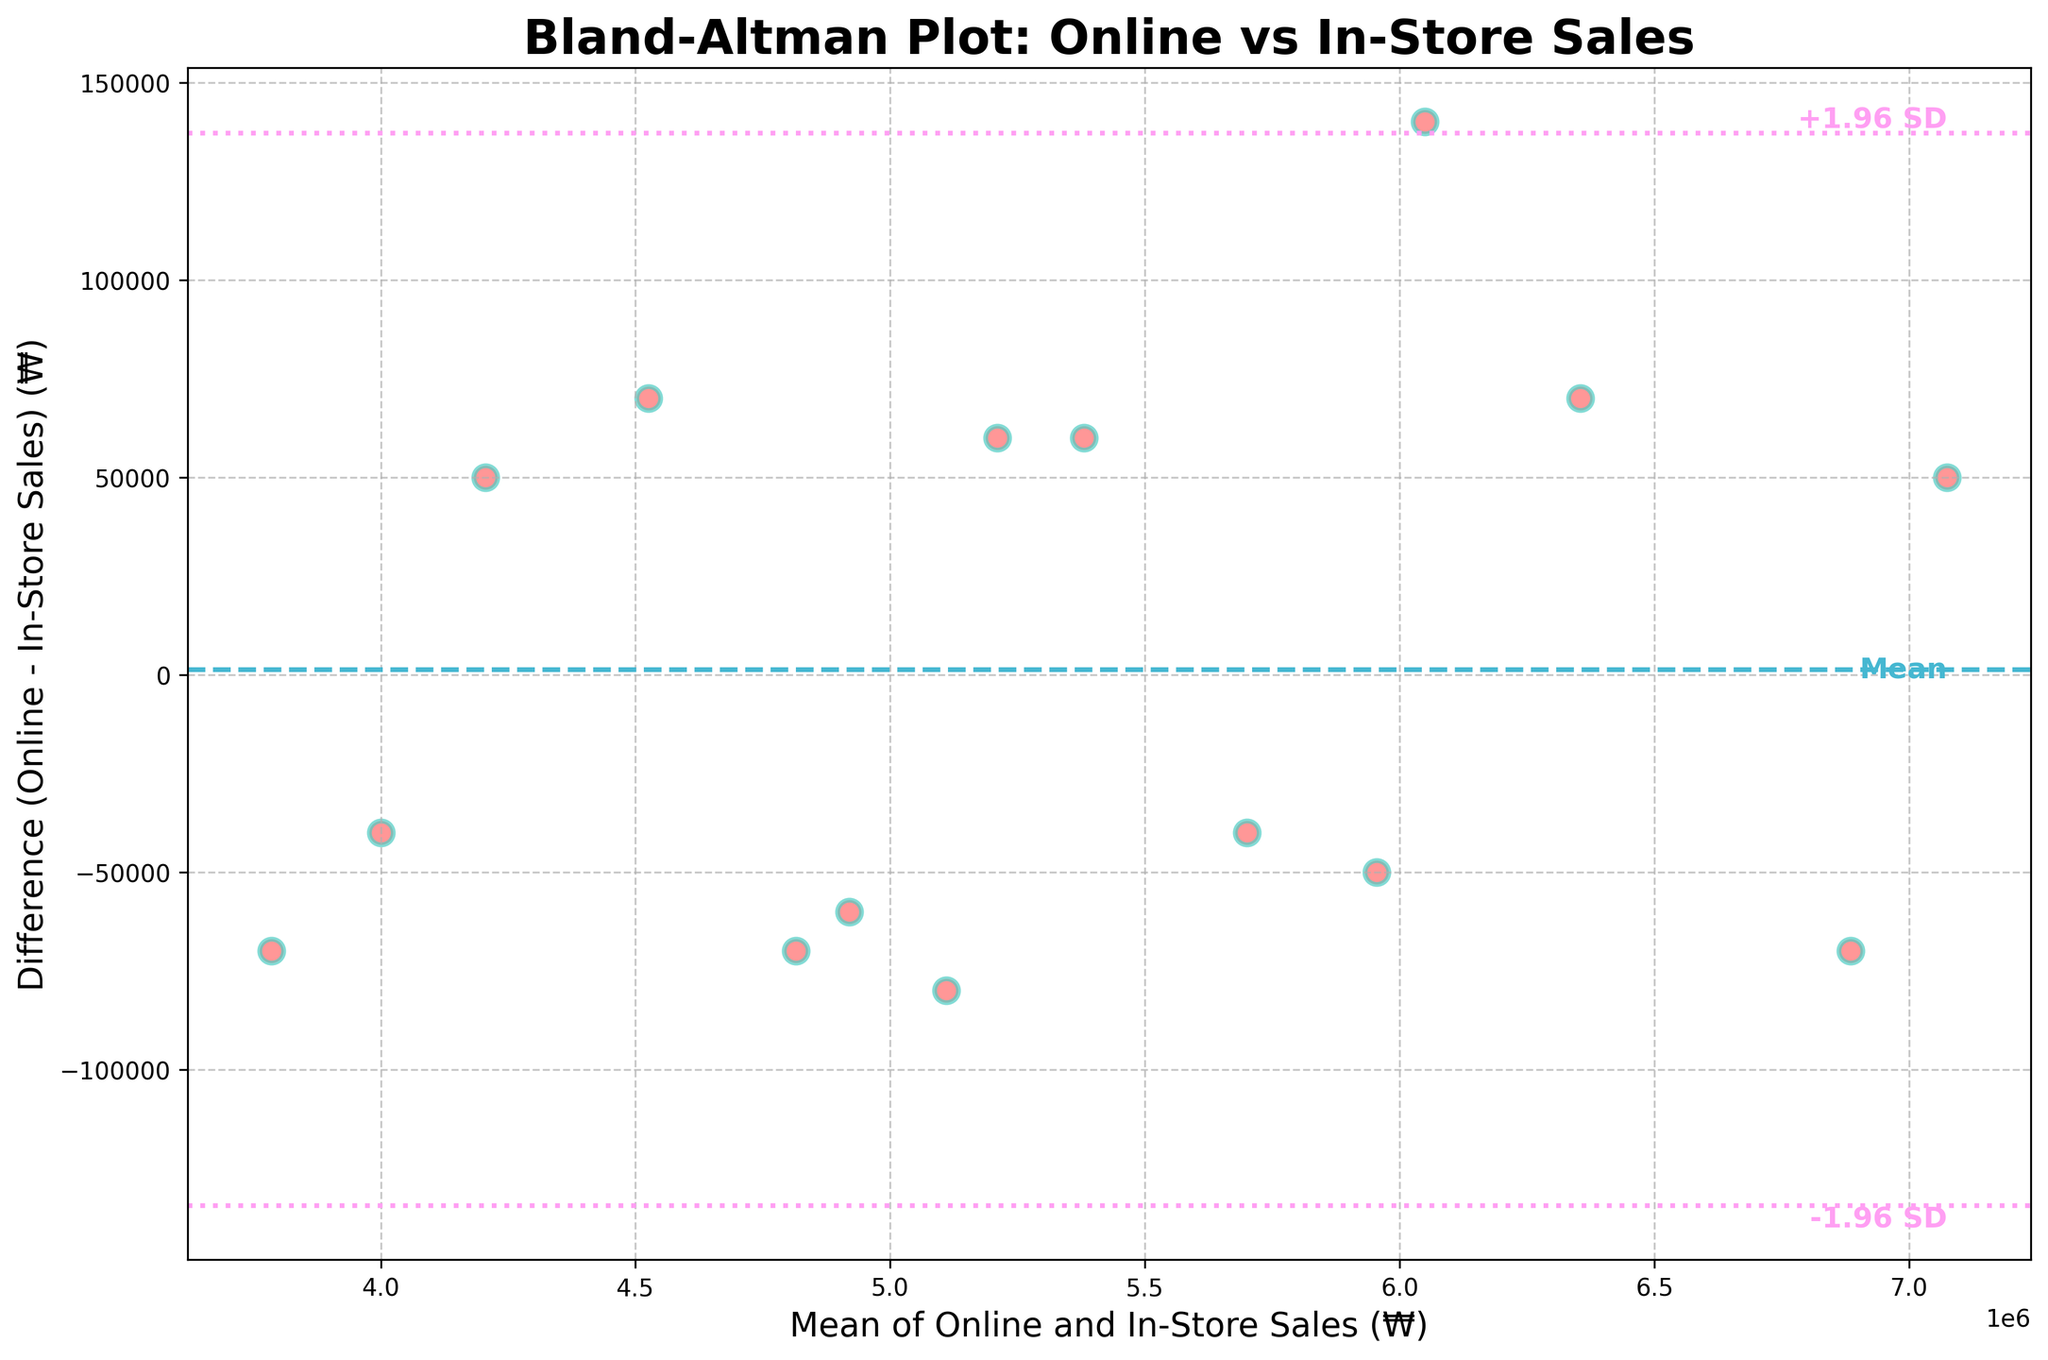what is the title of the plot? The title of the plot is usually displayed at the top, centered. In this case, the title is "Bland-Altman Plot: Online vs In-Store Sales".
Answer: Bland-Altman Plot: Online vs In-Store Sales How many data points are shown on the plot? Data points on the plot are represented by individual markers (e.g., dots or circles). Counting these markers on the plot will provide the number of data points.
Answer: 15 What is the average difference between online and in-store sales, as indicated by the horizontal line in the middle? The horizontal line in the middle of the plot represents the mean difference (average difference) between online and in-store sales. This is labeled as "Mean".
Answer: Mean difference What do the dashed lines at the top and bottom represent? The dashed lines above and below the mean line represent the limits of agreement, typically set at mean ± 1.96 standard deviations. These are labeled as "+1.96 SD" and "-1.96 SD".
Answer: Limits of agreement Is the variation in differences larger or smaller for higher mean sales values? Observe the spread of the data points along the y-axis (difference) as you move from left (lower mean sales values) to right (higher mean sales values). Larger spread indicates larger variation.
Answer: Smaller Which data point has the maximum mean sales value, and what is its difference? Identify the data point on the plot that is the furthest right (highest mean sales). The corresponding y-value of this point gives the difference between online and in-store sales for this data point.
Answer: Maximum Mean Sales Are there more data points with positive differences or negative differences? Count the number of data points above the mean difference line for positive differences and below it for negative differences. Compare these counts to determine which is higher.
Answer: Positive differences How do the differences vary close to the mean difference line? Examine the spread of data points near the mean difference line. If they are tightly clustered, the variance is low; if spread widely, the variance is high.
Answer: Low variance What do points that are far outside the ±1.96 SD lines indicate? Points outside these lines indicate data points where the difference between online and in-store sales is unusually high or low, suggesting potential outliers or anomalies.
Answer: Outliers Is there a noticeable trend or pattern in the differences as the mean sales value increases? Look for any discernible patterns, such as an increase or decrease in the spread of differences (y-values) as the mean sales value (x-values) increases.
Answer: No clear pattern 